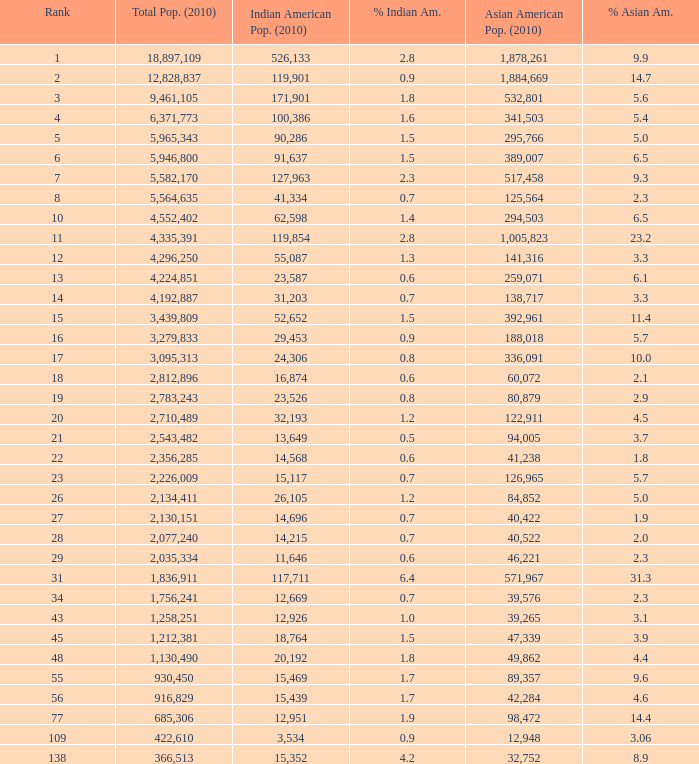What's the total population when there are 5.7% Asian American and fewer than 126,965 Asian American Population? None. 